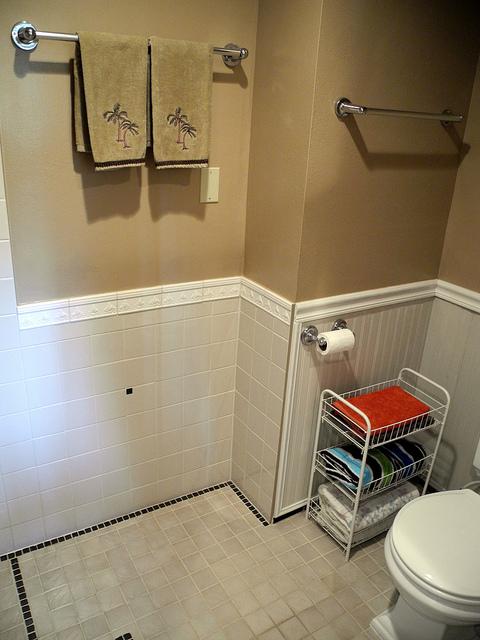What number of towels are on the towel rack?
Be succinct. 2. Is there a reflection in the mirror?
Short answer required. No. What are the floors made of?
Quick response, please. Tile. What color are walls painted?
Give a very brief answer. Tan. 